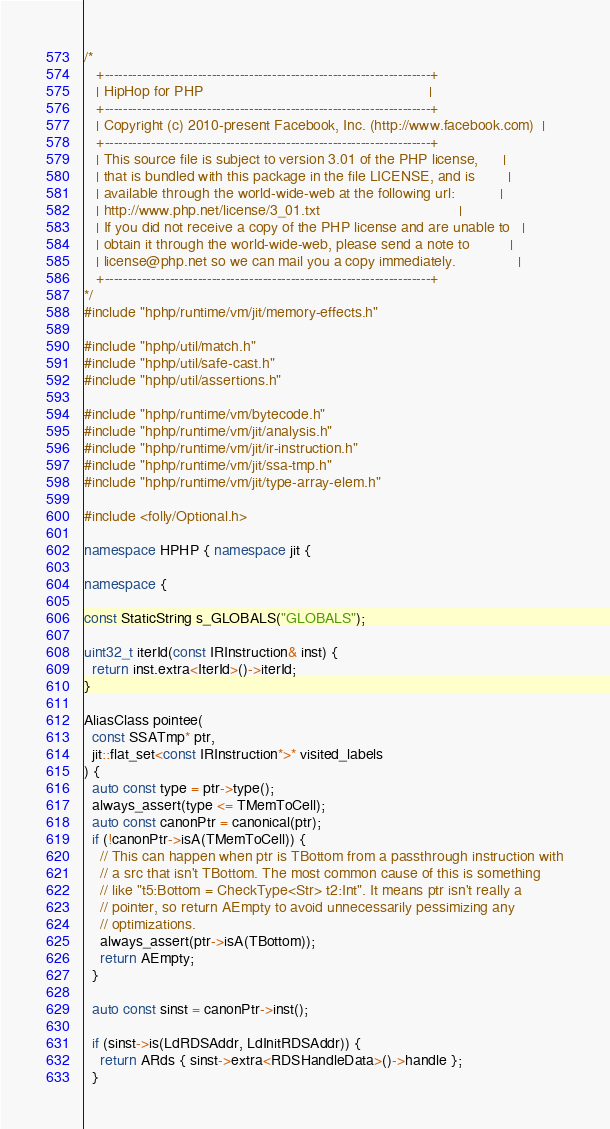Convert code to text. <code><loc_0><loc_0><loc_500><loc_500><_C++_>/*
   +----------------------------------------------------------------------+
   | HipHop for PHP                                                       |
   +----------------------------------------------------------------------+
   | Copyright (c) 2010-present Facebook, Inc. (http://www.facebook.com)  |
   +----------------------------------------------------------------------+
   | This source file is subject to version 3.01 of the PHP license,      |
   | that is bundled with this package in the file LICENSE, and is        |
   | available through the world-wide-web at the following url:           |
   | http://www.php.net/license/3_01.txt                                  |
   | If you did not receive a copy of the PHP license and are unable to   |
   | obtain it through the world-wide-web, please send a note to          |
   | license@php.net so we can mail you a copy immediately.               |
   +----------------------------------------------------------------------+
*/
#include "hphp/runtime/vm/jit/memory-effects.h"

#include "hphp/util/match.h"
#include "hphp/util/safe-cast.h"
#include "hphp/util/assertions.h"

#include "hphp/runtime/vm/bytecode.h"
#include "hphp/runtime/vm/jit/analysis.h"
#include "hphp/runtime/vm/jit/ir-instruction.h"
#include "hphp/runtime/vm/jit/ssa-tmp.h"
#include "hphp/runtime/vm/jit/type-array-elem.h"

#include <folly/Optional.h>

namespace HPHP { namespace jit {

namespace {

const StaticString s_GLOBALS("GLOBALS");

uint32_t iterId(const IRInstruction& inst) {
  return inst.extra<IterId>()->iterId;
}

AliasClass pointee(
  const SSATmp* ptr,
  jit::flat_set<const IRInstruction*>* visited_labels
) {
  auto const type = ptr->type();
  always_assert(type <= TMemToCell);
  auto const canonPtr = canonical(ptr);
  if (!canonPtr->isA(TMemToCell)) {
    // This can happen when ptr is TBottom from a passthrough instruction with
    // a src that isn't TBottom. The most common cause of this is something
    // like "t5:Bottom = CheckType<Str> t2:Int". It means ptr isn't really a
    // pointer, so return AEmpty to avoid unnecessarily pessimizing any
    // optimizations.
    always_assert(ptr->isA(TBottom));
    return AEmpty;
  }

  auto const sinst = canonPtr->inst();

  if (sinst->is(LdRDSAddr, LdInitRDSAddr)) {
    return ARds { sinst->extra<RDSHandleData>()->handle };
  }
</code> 